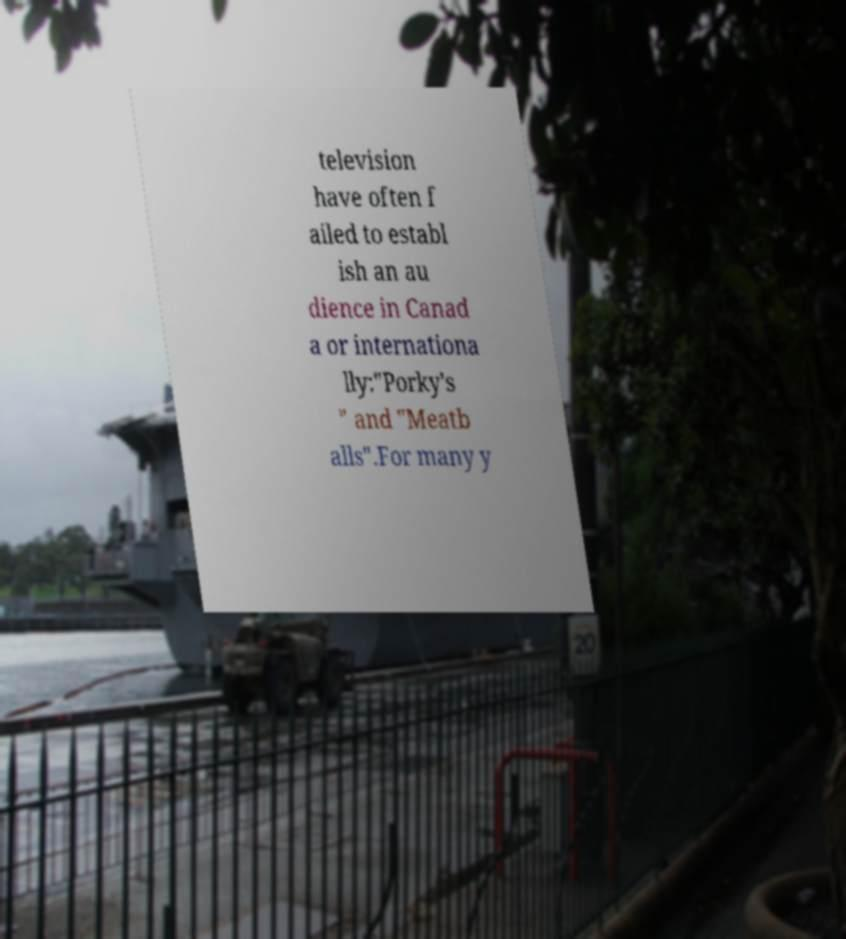There's text embedded in this image that I need extracted. Can you transcribe it verbatim? television have often f ailed to establ ish an au dience in Canad a or internationa lly:"Porky's " and "Meatb alls".For many y 